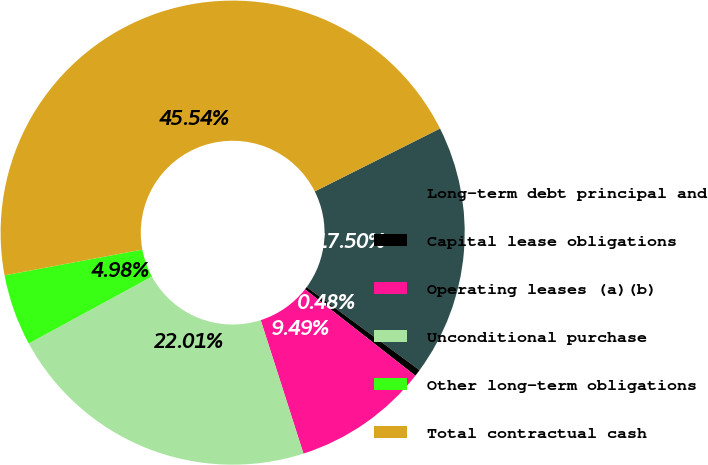Convert chart to OTSL. <chart><loc_0><loc_0><loc_500><loc_500><pie_chart><fcel>Long-term debt principal and<fcel>Capital lease obligations<fcel>Operating leases (a)(b)<fcel>Unconditional purchase<fcel>Other long-term obligations<fcel>Total contractual cash<nl><fcel>17.5%<fcel>0.48%<fcel>9.49%<fcel>22.01%<fcel>4.98%<fcel>45.54%<nl></chart> 